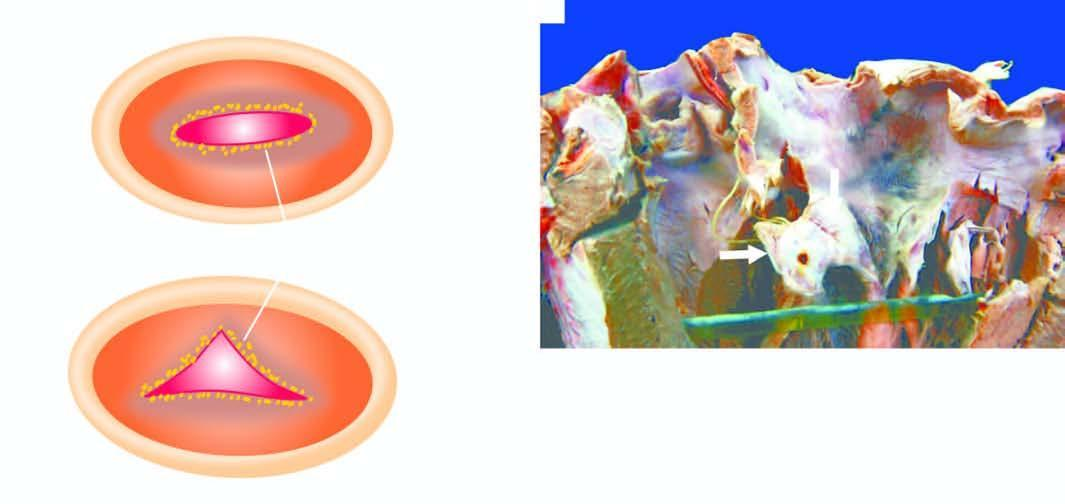b irregularly scarred mitral valve leaving a fish-mouth or buttonhole opening between whose two cusps black arrow?
Answer the question using a single word or phrase. Its 